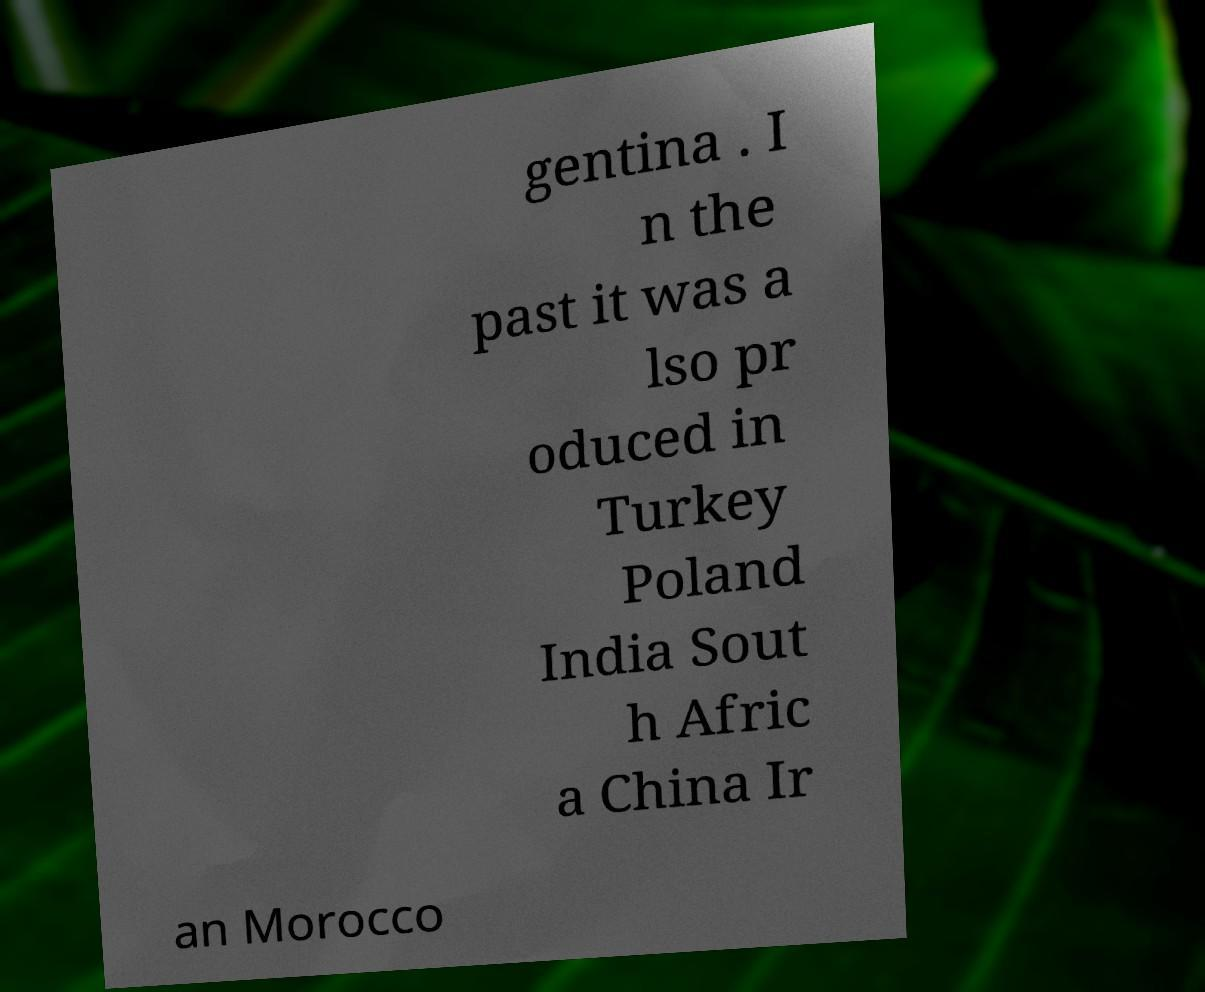Please identify and transcribe the text found in this image. gentina . I n the past it was a lso pr oduced in Turkey Poland India Sout h Afric a China Ir an Morocco 